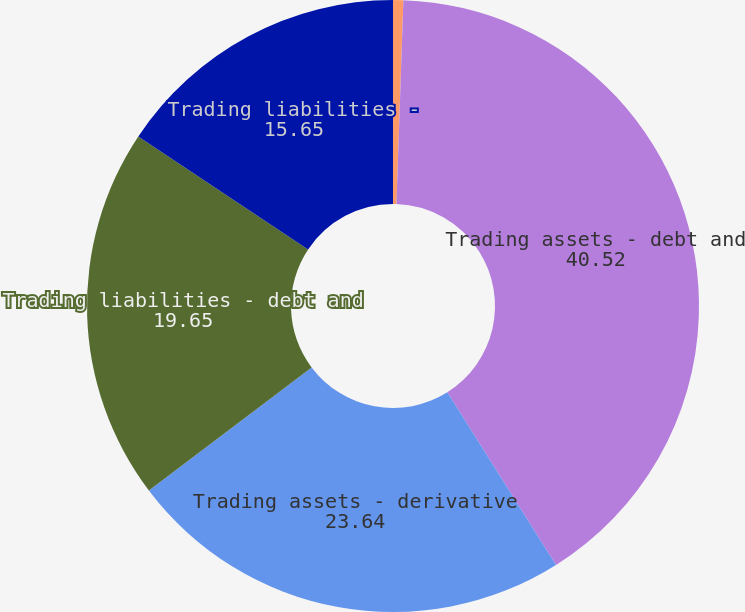<chart> <loc_0><loc_0><loc_500><loc_500><pie_chart><fcel>Year ended December 31 (in<fcel>Trading assets - debt and<fcel>Trading assets - derivative<fcel>Trading liabilities - debt and<fcel>Trading liabilities -<nl><fcel>0.54%<fcel>40.52%<fcel>23.64%<fcel>19.65%<fcel>15.65%<nl></chart> 